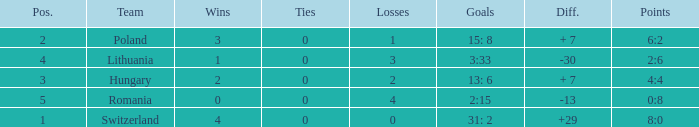Which team had fewer than 2 losses and a position number more than 1? Poland. Parse the full table. {'header': ['Pos.', 'Team', 'Wins', 'Ties', 'Losses', 'Goals', 'Diff.', 'Points'], 'rows': [['2', 'Poland', '3', '0', '1', '15: 8', '+ 7', '6:2'], ['4', 'Lithuania', '1', '0', '3', '3:33', '-30', '2:6'], ['3', 'Hungary', '2', '0', '2', '13: 6', '+ 7', '4:4'], ['5', 'Romania', '0', '0', '4', '2:15', '-13', '0:8'], ['1', 'Switzerland', '4', '0', '0', '31: 2', '+29', '8:0']]} 